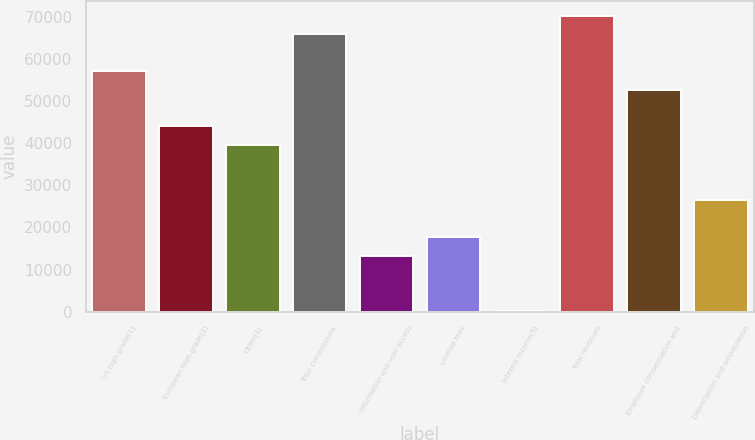Convert chart to OTSL. <chart><loc_0><loc_0><loc_500><loc_500><bar_chart><fcel>US high-grade(1)<fcel>European high-grade(2)<fcel>Other(3)<fcel>Total commissions<fcel>Information and user access<fcel>License fees<fcel>Interest income(5)<fcel>Total revenues<fcel>Employee compensation and<fcel>Depreciation and amortization<nl><fcel>57158.7<fcel>43995<fcel>39607.1<fcel>65934.5<fcel>13279.7<fcel>17667.6<fcel>116<fcel>70322.4<fcel>52770.8<fcel>26443.4<nl></chart> 